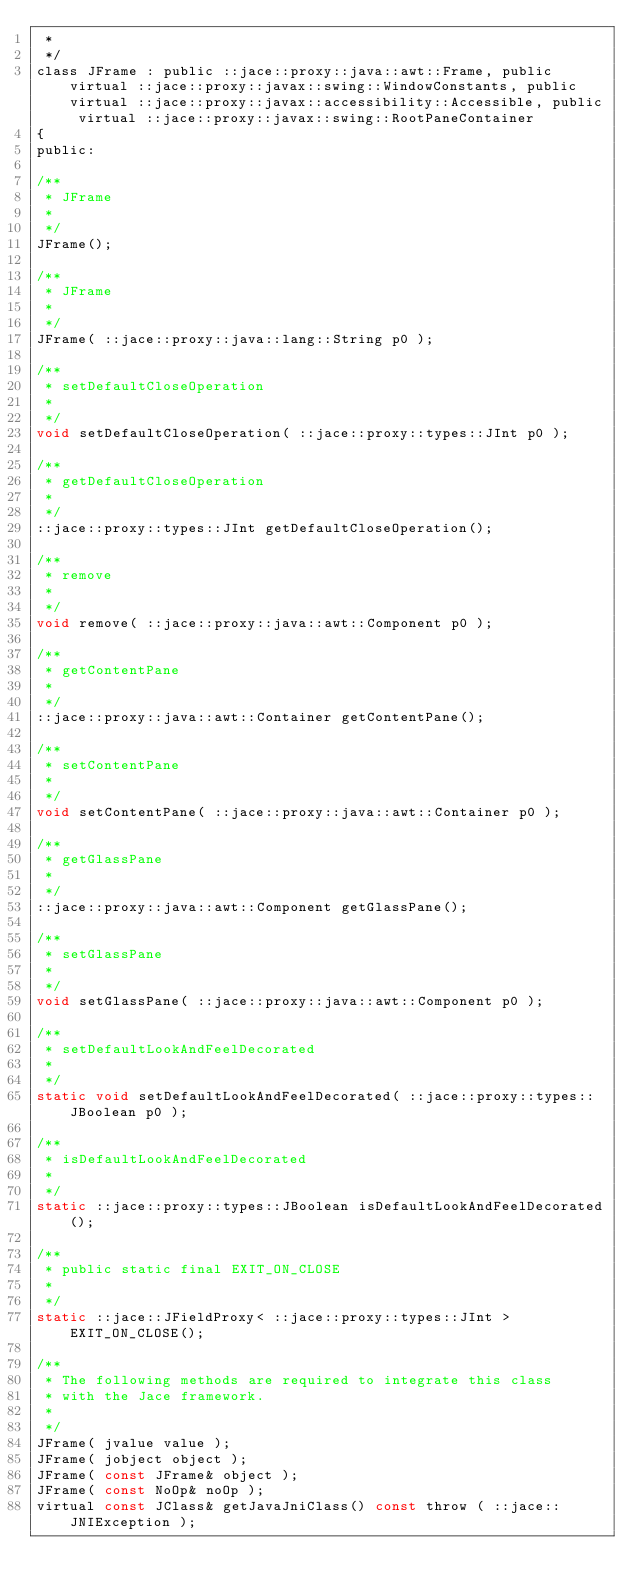Convert code to text. <code><loc_0><loc_0><loc_500><loc_500><_C_> *
 */
class JFrame : public ::jace::proxy::java::awt::Frame, public virtual ::jace::proxy::javax::swing::WindowConstants, public virtual ::jace::proxy::javax::accessibility::Accessible, public virtual ::jace::proxy::javax::swing::RootPaneContainer
{
public: 

/**
 * JFrame
 *
 */
JFrame();

/**
 * JFrame
 *
 */
JFrame( ::jace::proxy::java::lang::String p0 );

/**
 * setDefaultCloseOperation
 *
 */
void setDefaultCloseOperation( ::jace::proxy::types::JInt p0 );

/**
 * getDefaultCloseOperation
 *
 */
::jace::proxy::types::JInt getDefaultCloseOperation();

/**
 * remove
 *
 */
void remove( ::jace::proxy::java::awt::Component p0 );

/**
 * getContentPane
 *
 */
::jace::proxy::java::awt::Container getContentPane();

/**
 * setContentPane
 *
 */
void setContentPane( ::jace::proxy::java::awt::Container p0 );

/**
 * getGlassPane
 *
 */
::jace::proxy::java::awt::Component getGlassPane();

/**
 * setGlassPane
 *
 */
void setGlassPane( ::jace::proxy::java::awt::Component p0 );

/**
 * setDefaultLookAndFeelDecorated
 *
 */
static void setDefaultLookAndFeelDecorated( ::jace::proxy::types::JBoolean p0 );

/**
 * isDefaultLookAndFeelDecorated
 *
 */
static ::jace::proxy::types::JBoolean isDefaultLookAndFeelDecorated();

/**
 * public static final EXIT_ON_CLOSE
 *
 */
static ::jace::JFieldProxy< ::jace::proxy::types::JInt > EXIT_ON_CLOSE();

/**
 * The following methods are required to integrate this class
 * with the Jace framework.
 *
 */
JFrame( jvalue value );
JFrame( jobject object );
JFrame( const JFrame& object );
JFrame( const NoOp& noOp );
virtual const JClass& getJavaJniClass() const throw ( ::jace::JNIException );</code> 